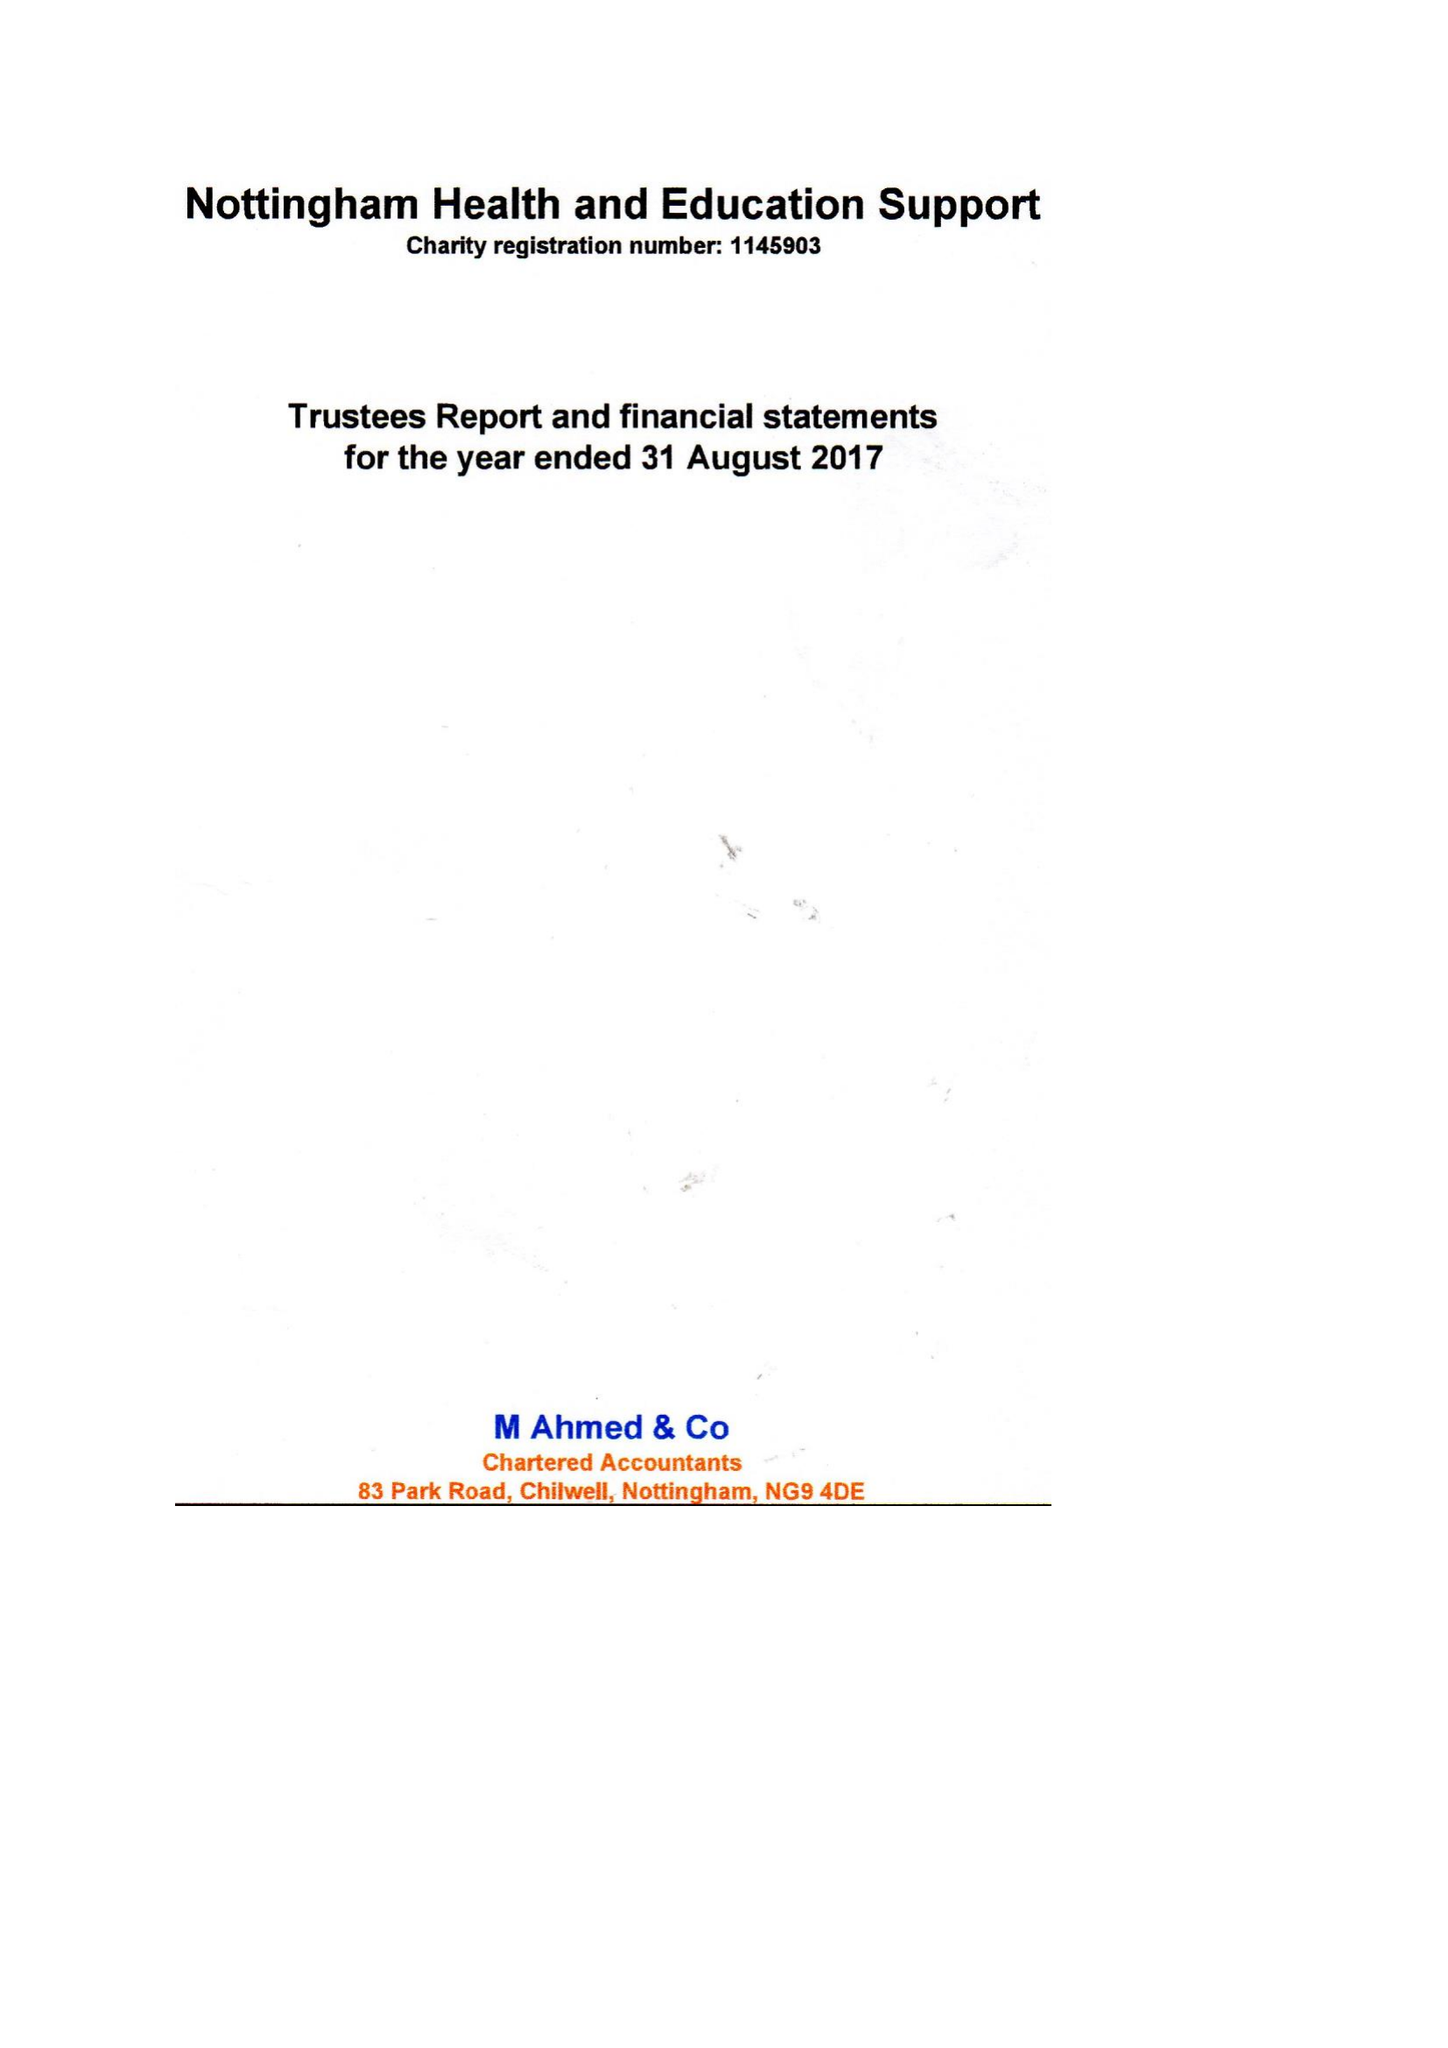What is the value for the charity_number?
Answer the question using a single word or phrase. 1145903 